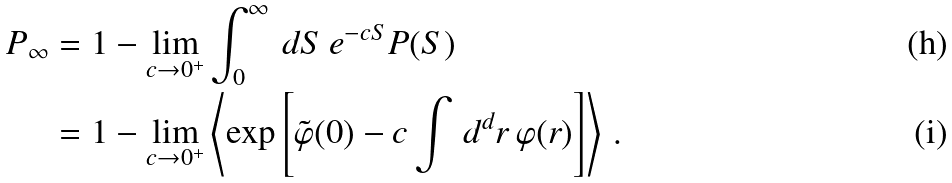<formula> <loc_0><loc_0><loc_500><loc_500>P _ { \infty } & = 1 - \lim _ { c \to 0 ^ { + } } \int _ { 0 } ^ { \infty } \, d S \, e ^ { - c S } P ( S ) \\ & = 1 - \lim _ { c \to 0 ^ { + } } \left \langle \exp \left [ \tilde { \varphi } ( 0 ) - c \int \, d ^ { d } r \, \varphi ( r ) \right ] \right \rangle \, .</formula> 